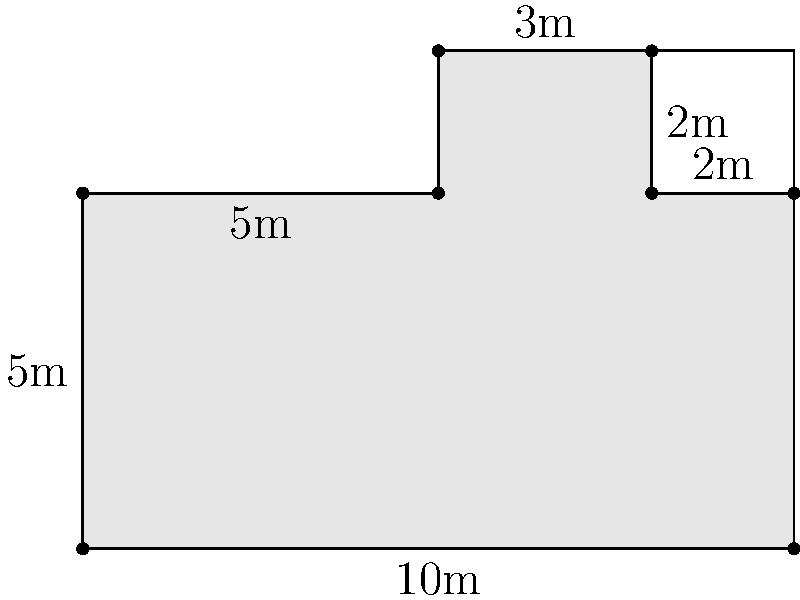In a high-profile case, you need to determine the exact area of the courtroom to argue that it was too small for the number of spectators present, potentially influencing the jury. The courtroom has an irregular shape, as shown in the floor plan above. All measurements are in meters. What is the total area of the courtroom in square meters? To calculate the area of this irregular shape, we'll break it down into rectangles:

1. Main rectangle: 
   $10\text{m} \times 5\text{m} = 50\text{m}^2$

2. Upper left rectangle:
   $5\text{m} \times 2\text{m} = 10\text{m}^2$

3. Upper right rectangle (alcove):
   $2\text{m} \times 2\text{m} = 4\text{m}^2$

Now, we need to add the areas of the main rectangle and the upper left rectangle, but subtract the area of the alcove (as it's not part of the courtroom):

Total Area $= 50\text{m}^2 + 10\text{m}^2 - 4\text{m}^2 = 56\text{m}^2$

Therefore, the total area of the courtroom is 56 square meters.
Answer: $56\text{m}^2$ 